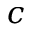<formula> <loc_0><loc_0><loc_500><loc_500>c</formula> 